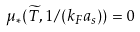Convert formula to latex. <formula><loc_0><loc_0><loc_500><loc_500>\mu _ { * } ( { \widetilde { T } } , 1 / ( k _ { F } a _ { s } ) ) = 0</formula> 